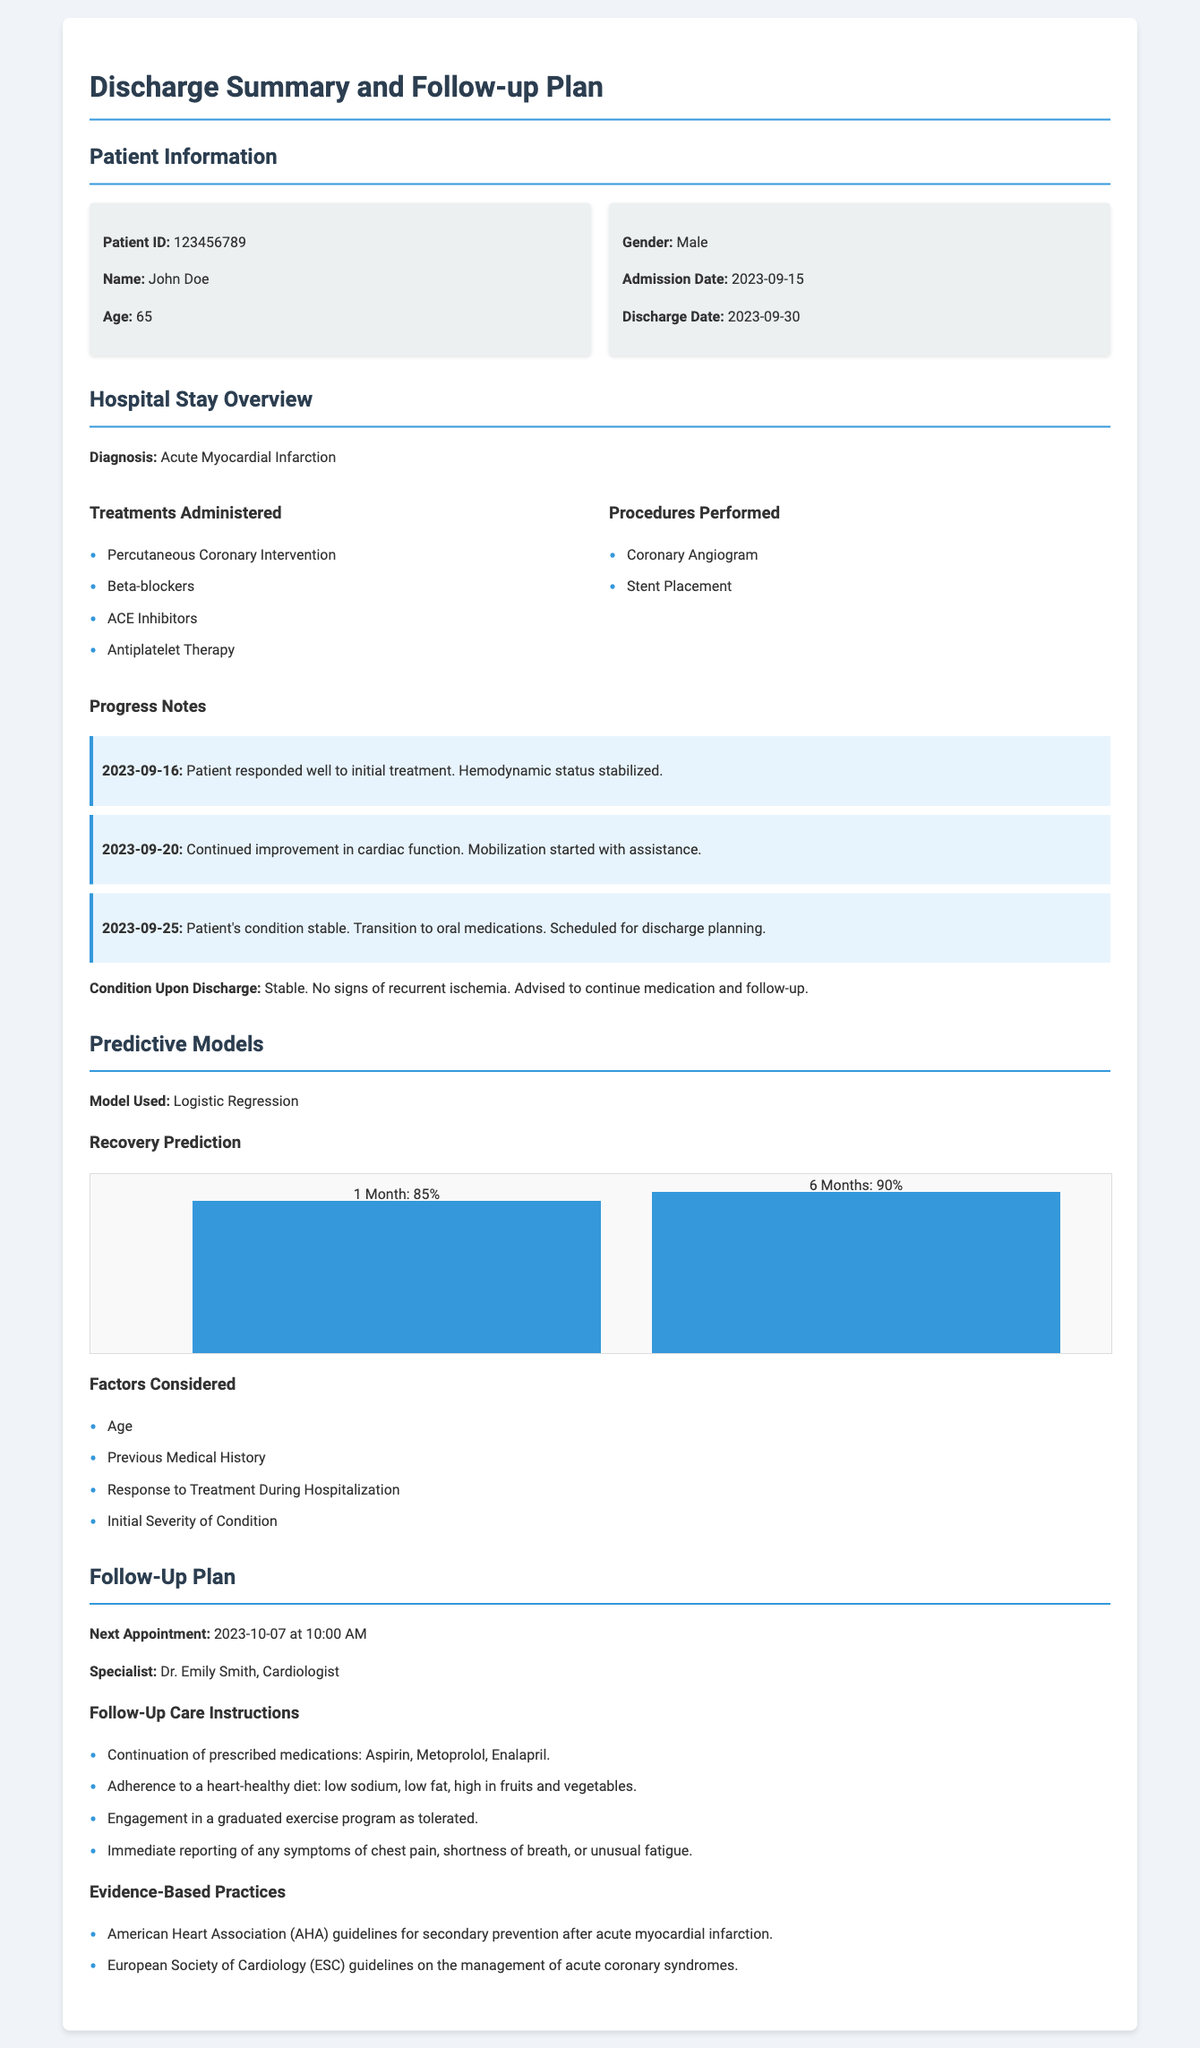What is the patient's name? The patient's name is provided in the Patient Information section.
Answer: John Doe What is the diagnosis? The diagnosis can be found in the Hospital Stay Overview section.
Answer: Acute Myocardial Infarction When was the patient admitted? The admission date is listed in the Patient Information section.
Answer: 2023-09-15 What percentage is the 6-month recovery prediction? The recovery prediction for 6 months is discussed in the Predictive Models section.
Answer: 90% Who is the follow-up specialist? The specialist's name is mentioned in the Follow-Up Plan section.
Answer: Dr. Emily Smith What treatment was administered related to heart function? One of the treatments listed in the Hospital Stay Overview addresses cardiac care.
Answer: Beta-blockers What is the next appointment date? The next appointment date is outlined in the Follow-Up Plan section.
Answer: 2023-10-07 Which guideline is mentioned for secondary prevention? The document specifies practices from recognized organizations relating to heart health.
Answer: American Heart Association (AHA) guidelines 